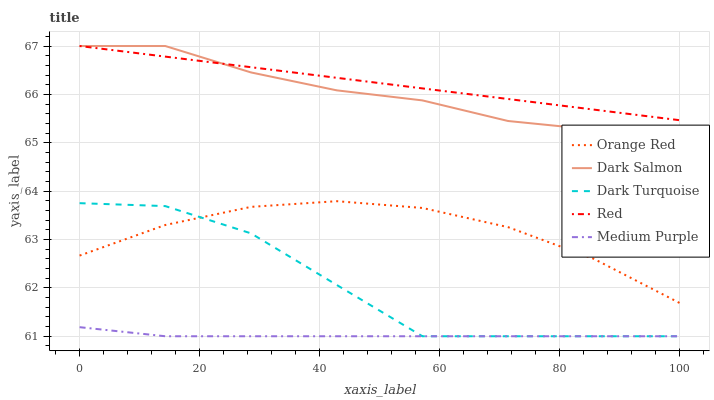Does Dark Turquoise have the minimum area under the curve?
Answer yes or no. No. Does Dark Turquoise have the maximum area under the curve?
Answer yes or no. No. Is Orange Red the smoothest?
Answer yes or no. No. Is Orange Red the roughest?
Answer yes or no. No. Does Orange Red have the lowest value?
Answer yes or no. No. Does Dark Turquoise have the highest value?
Answer yes or no. No. Is Orange Red less than Red?
Answer yes or no. Yes. Is Red greater than Medium Purple?
Answer yes or no. Yes. Does Orange Red intersect Red?
Answer yes or no. No. 